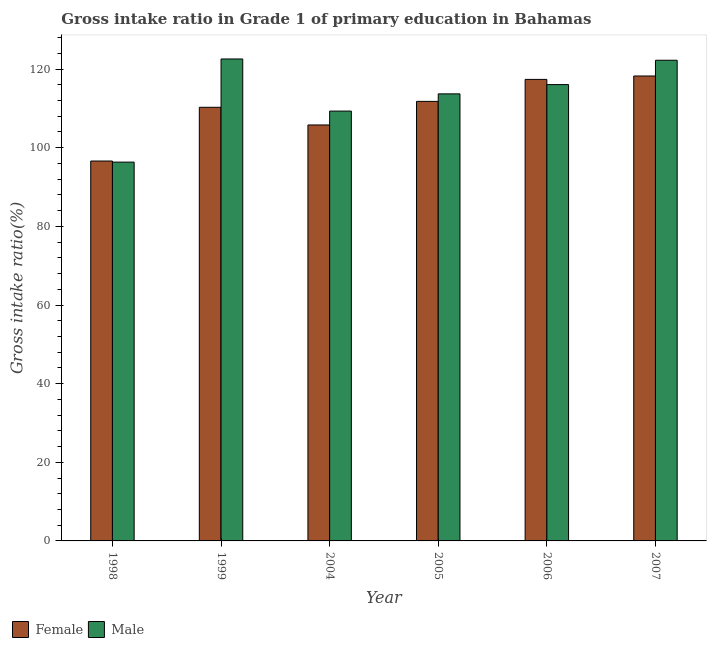How many different coloured bars are there?
Provide a short and direct response. 2. Are the number of bars on each tick of the X-axis equal?
Ensure brevity in your answer.  Yes. What is the label of the 6th group of bars from the left?
Your answer should be compact. 2007. What is the gross intake ratio(female) in 2007?
Your answer should be compact. 118.24. Across all years, what is the maximum gross intake ratio(female)?
Your answer should be very brief. 118.24. Across all years, what is the minimum gross intake ratio(male)?
Make the answer very short. 96.34. What is the total gross intake ratio(female) in the graph?
Your response must be concise. 660.1. What is the difference between the gross intake ratio(female) in 1999 and that in 2006?
Give a very brief answer. -7.1. What is the difference between the gross intake ratio(female) in 2006 and the gross intake ratio(male) in 2007?
Offer a terse response. -0.87. What is the average gross intake ratio(male) per year?
Make the answer very short. 113.37. In how many years, is the gross intake ratio(female) greater than 80 %?
Provide a short and direct response. 6. What is the ratio of the gross intake ratio(female) in 1999 to that in 2007?
Make the answer very short. 0.93. Is the gross intake ratio(female) in 2004 less than that in 2007?
Your response must be concise. Yes. What is the difference between the highest and the second highest gross intake ratio(male)?
Give a very brief answer. 0.32. What is the difference between the highest and the lowest gross intake ratio(male)?
Your answer should be very brief. 26.23. Is the sum of the gross intake ratio(male) in 2005 and 2006 greater than the maximum gross intake ratio(female) across all years?
Your response must be concise. Yes. What does the 2nd bar from the right in 1999 represents?
Your response must be concise. Female. How many bars are there?
Offer a terse response. 12. How many years are there in the graph?
Provide a succinct answer. 6. What is the difference between two consecutive major ticks on the Y-axis?
Make the answer very short. 20. Are the values on the major ticks of Y-axis written in scientific E-notation?
Give a very brief answer. No. Does the graph contain grids?
Offer a terse response. No. How many legend labels are there?
Your answer should be compact. 2. What is the title of the graph?
Provide a succinct answer. Gross intake ratio in Grade 1 of primary education in Bahamas. What is the label or title of the Y-axis?
Your response must be concise. Gross intake ratio(%). What is the Gross intake ratio(%) of Female in 1998?
Offer a terse response. 96.62. What is the Gross intake ratio(%) in Male in 1998?
Your response must be concise. 96.34. What is the Gross intake ratio(%) in Female in 1999?
Keep it short and to the point. 110.28. What is the Gross intake ratio(%) in Male in 1999?
Ensure brevity in your answer.  122.57. What is the Gross intake ratio(%) of Female in 2004?
Your answer should be compact. 105.79. What is the Gross intake ratio(%) of Male in 2004?
Keep it short and to the point. 109.32. What is the Gross intake ratio(%) in Female in 2005?
Your answer should be compact. 111.79. What is the Gross intake ratio(%) of Male in 2005?
Keep it short and to the point. 113.7. What is the Gross intake ratio(%) in Female in 2006?
Provide a succinct answer. 117.38. What is the Gross intake ratio(%) in Male in 2006?
Your response must be concise. 116.06. What is the Gross intake ratio(%) in Female in 2007?
Ensure brevity in your answer.  118.24. What is the Gross intake ratio(%) of Male in 2007?
Make the answer very short. 122.25. Across all years, what is the maximum Gross intake ratio(%) in Female?
Ensure brevity in your answer.  118.24. Across all years, what is the maximum Gross intake ratio(%) of Male?
Your answer should be compact. 122.57. Across all years, what is the minimum Gross intake ratio(%) in Female?
Give a very brief answer. 96.62. Across all years, what is the minimum Gross intake ratio(%) of Male?
Make the answer very short. 96.34. What is the total Gross intake ratio(%) in Female in the graph?
Provide a short and direct response. 660.1. What is the total Gross intake ratio(%) of Male in the graph?
Keep it short and to the point. 680.23. What is the difference between the Gross intake ratio(%) of Female in 1998 and that in 1999?
Your answer should be compact. -13.66. What is the difference between the Gross intake ratio(%) of Male in 1998 and that in 1999?
Your answer should be compact. -26.23. What is the difference between the Gross intake ratio(%) in Female in 1998 and that in 2004?
Offer a terse response. -9.17. What is the difference between the Gross intake ratio(%) in Male in 1998 and that in 2004?
Your answer should be compact. -12.98. What is the difference between the Gross intake ratio(%) of Female in 1998 and that in 2005?
Your answer should be very brief. -15.17. What is the difference between the Gross intake ratio(%) of Male in 1998 and that in 2005?
Give a very brief answer. -17.36. What is the difference between the Gross intake ratio(%) of Female in 1998 and that in 2006?
Offer a terse response. -20.76. What is the difference between the Gross intake ratio(%) in Male in 1998 and that in 2006?
Provide a succinct answer. -19.72. What is the difference between the Gross intake ratio(%) of Female in 1998 and that in 2007?
Offer a very short reply. -21.63. What is the difference between the Gross intake ratio(%) in Male in 1998 and that in 2007?
Offer a terse response. -25.91. What is the difference between the Gross intake ratio(%) of Female in 1999 and that in 2004?
Your answer should be compact. 4.49. What is the difference between the Gross intake ratio(%) of Male in 1999 and that in 2004?
Provide a short and direct response. 13.25. What is the difference between the Gross intake ratio(%) of Female in 1999 and that in 2005?
Your answer should be compact. -1.51. What is the difference between the Gross intake ratio(%) in Male in 1999 and that in 2005?
Make the answer very short. 8.87. What is the difference between the Gross intake ratio(%) of Female in 1999 and that in 2006?
Ensure brevity in your answer.  -7.1. What is the difference between the Gross intake ratio(%) in Male in 1999 and that in 2006?
Offer a very short reply. 6.51. What is the difference between the Gross intake ratio(%) of Female in 1999 and that in 2007?
Your answer should be compact. -7.96. What is the difference between the Gross intake ratio(%) in Male in 1999 and that in 2007?
Make the answer very short. 0.32. What is the difference between the Gross intake ratio(%) in Female in 2004 and that in 2005?
Keep it short and to the point. -6. What is the difference between the Gross intake ratio(%) of Male in 2004 and that in 2005?
Provide a short and direct response. -4.38. What is the difference between the Gross intake ratio(%) in Female in 2004 and that in 2006?
Keep it short and to the point. -11.59. What is the difference between the Gross intake ratio(%) of Male in 2004 and that in 2006?
Offer a very short reply. -6.74. What is the difference between the Gross intake ratio(%) of Female in 2004 and that in 2007?
Ensure brevity in your answer.  -12.46. What is the difference between the Gross intake ratio(%) in Male in 2004 and that in 2007?
Your response must be concise. -12.93. What is the difference between the Gross intake ratio(%) in Female in 2005 and that in 2006?
Give a very brief answer. -5.59. What is the difference between the Gross intake ratio(%) in Male in 2005 and that in 2006?
Provide a short and direct response. -2.36. What is the difference between the Gross intake ratio(%) of Female in 2005 and that in 2007?
Make the answer very short. -6.46. What is the difference between the Gross intake ratio(%) in Male in 2005 and that in 2007?
Provide a succinct answer. -8.55. What is the difference between the Gross intake ratio(%) of Female in 2006 and that in 2007?
Provide a succinct answer. -0.87. What is the difference between the Gross intake ratio(%) in Male in 2006 and that in 2007?
Your answer should be compact. -6.19. What is the difference between the Gross intake ratio(%) in Female in 1998 and the Gross intake ratio(%) in Male in 1999?
Offer a terse response. -25.95. What is the difference between the Gross intake ratio(%) of Female in 1998 and the Gross intake ratio(%) of Male in 2004?
Ensure brevity in your answer.  -12.7. What is the difference between the Gross intake ratio(%) of Female in 1998 and the Gross intake ratio(%) of Male in 2005?
Provide a short and direct response. -17.08. What is the difference between the Gross intake ratio(%) of Female in 1998 and the Gross intake ratio(%) of Male in 2006?
Provide a short and direct response. -19.44. What is the difference between the Gross intake ratio(%) of Female in 1998 and the Gross intake ratio(%) of Male in 2007?
Give a very brief answer. -25.63. What is the difference between the Gross intake ratio(%) in Female in 1999 and the Gross intake ratio(%) in Male in 2004?
Offer a terse response. 0.96. What is the difference between the Gross intake ratio(%) in Female in 1999 and the Gross intake ratio(%) in Male in 2005?
Give a very brief answer. -3.42. What is the difference between the Gross intake ratio(%) of Female in 1999 and the Gross intake ratio(%) of Male in 2006?
Provide a succinct answer. -5.78. What is the difference between the Gross intake ratio(%) in Female in 1999 and the Gross intake ratio(%) in Male in 2007?
Offer a very short reply. -11.97. What is the difference between the Gross intake ratio(%) of Female in 2004 and the Gross intake ratio(%) of Male in 2005?
Offer a very short reply. -7.91. What is the difference between the Gross intake ratio(%) in Female in 2004 and the Gross intake ratio(%) in Male in 2006?
Give a very brief answer. -10.27. What is the difference between the Gross intake ratio(%) in Female in 2004 and the Gross intake ratio(%) in Male in 2007?
Your response must be concise. -16.46. What is the difference between the Gross intake ratio(%) in Female in 2005 and the Gross intake ratio(%) in Male in 2006?
Your answer should be very brief. -4.27. What is the difference between the Gross intake ratio(%) of Female in 2005 and the Gross intake ratio(%) of Male in 2007?
Your answer should be very brief. -10.46. What is the difference between the Gross intake ratio(%) of Female in 2006 and the Gross intake ratio(%) of Male in 2007?
Make the answer very short. -4.87. What is the average Gross intake ratio(%) of Female per year?
Ensure brevity in your answer.  110.02. What is the average Gross intake ratio(%) in Male per year?
Ensure brevity in your answer.  113.37. In the year 1998, what is the difference between the Gross intake ratio(%) in Female and Gross intake ratio(%) in Male?
Your answer should be very brief. 0.28. In the year 1999, what is the difference between the Gross intake ratio(%) in Female and Gross intake ratio(%) in Male?
Your answer should be compact. -12.29. In the year 2004, what is the difference between the Gross intake ratio(%) in Female and Gross intake ratio(%) in Male?
Ensure brevity in your answer.  -3.53. In the year 2005, what is the difference between the Gross intake ratio(%) in Female and Gross intake ratio(%) in Male?
Provide a succinct answer. -1.91. In the year 2006, what is the difference between the Gross intake ratio(%) in Female and Gross intake ratio(%) in Male?
Ensure brevity in your answer.  1.32. In the year 2007, what is the difference between the Gross intake ratio(%) in Female and Gross intake ratio(%) in Male?
Your answer should be compact. -4. What is the ratio of the Gross intake ratio(%) of Female in 1998 to that in 1999?
Provide a short and direct response. 0.88. What is the ratio of the Gross intake ratio(%) in Male in 1998 to that in 1999?
Keep it short and to the point. 0.79. What is the ratio of the Gross intake ratio(%) of Female in 1998 to that in 2004?
Your answer should be very brief. 0.91. What is the ratio of the Gross intake ratio(%) of Male in 1998 to that in 2004?
Offer a terse response. 0.88. What is the ratio of the Gross intake ratio(%) of Female in 1998 to that in 2005?
Give a very brief answer. 0.86. What is the ratio of the Gross intake ratio(%) of Male in 1998 to that in 2005?
Ensure brevity in your answer.  0.85. What is the ratio of the Gross intake ratio(%) of Female in 1998 to that in 2006?
Your answer should be very brief. 0.82. What is the ratio of the Gross intake ratio(%) of Male in 1998 to that in 2006?
Offer a terse response. 0.83. What is the ratio of the Gross intake ratio(%) in Female in 1998 to that in 2007?
Give a very brief answer. 0.82. What is the ratio of the Gross intake ratio(%) in Male in 1998 to that in 2007?
Provide a succinct answer. 0.79. What is the ratio of the Gross intake ratio(%) of Female in 1999 to that in 2004?
Ensure brevity in your answer.  1.04. What is the ratio of the Gross intake ratio(%) in Male in 1999 to that in 2004?
Make the answer very short. 1.12. What is the ratio of the Gross intake ratio(%) in Female in 1999 to that in 2005?
Your answer should be very brief. 0.99. What is the ratio of the Gross intake ratio(%) of Male in 1999 to that in 2005?
Ensure brevity in your answer.  1.08. What is the ratio of the Gross intake ratio(%) in Female in 1999 to that in 2006?
Your answer should be very brief. 0.94. What is the ratio of the Gross intake ratio(%) of Male in 1999 to that in 2006?
Your response must be concise. 1.06. What is the ratio of the Gross intake ratio(%) of Female in 1999 to that in 2007?
Offer a terse response. 0.93. What is the ratio of the Gross intake ratio(%) in Female in 2004 to that in 2005?
Make the answer very short. 0.95. What is the ratio of the Gross intake ratio(%) in Male in 2004 to that in 2005?
Offer a terse response. 0.96. What is the ratio of the Gross intake ratio(%) in Female in 2004 to that in 2006?
Your answer should be very brief. 0.9. What is the ratio of the Gross intake ratio(%) in Male in 2004 to that in 2006?
Offer a very short reply. 0.94. What is the ratio of the Gross intake ratio(%) of Female in 2004 to that in 2007?
Ensure brevity in your answer.  0.89. What is the ratio of the Gross intake ratio(%) of Male in 2004 to that in 2007?
Make the answer very short. 0.89. What is the ratio of the Gross intake ratio(%) of Male in 2005 to that in 2006?
Make the answer very short. 0.98. What is the ratio of the Gross intake ratio(%) of Female in 2005 to that in 2007?
Keep it short and to the point. 0.95. What is the ratio of the Gross intake ratio(%) of Male in 2005 to that in 2007?
Offer a very short reply. 0.93. What is the ratio of the Gross intake ratio(%) in Male in 2006 to that in 2007?
Offer a terse response. 0.95. What is the difference between the highest and the second highest Gross intake ratio(%) of Female?
Offer a terse response. 0.87. What is the difference between the highest and the second highest Gross intake ratio(%) of Male?
Your answer should be compact. 0.32. What is the difference between the highest and the lowest Gross intake ratio(%) of Female?
Provide a short and direct response. 21.63. What is the difference between the highest and the lowest Gross intake ratio(%) of Male?
Provide a short and direct response. 26.23. 